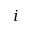<formula> <loc_0><loc_0><loc_500><loc_500>i</formula> 